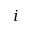<formula> <loc_0><loc_0><loc_500><loc_500>i</formula> 